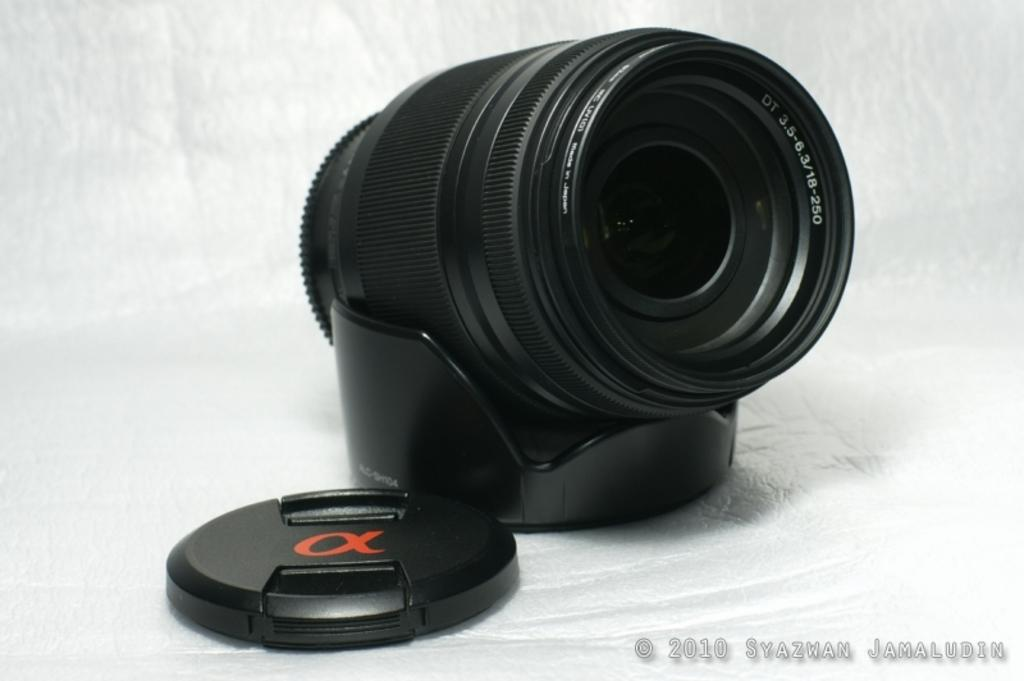<image>
Relay a brief, clear account of the picture shown. A picture of a camera and a lens with the copyright at 2010 